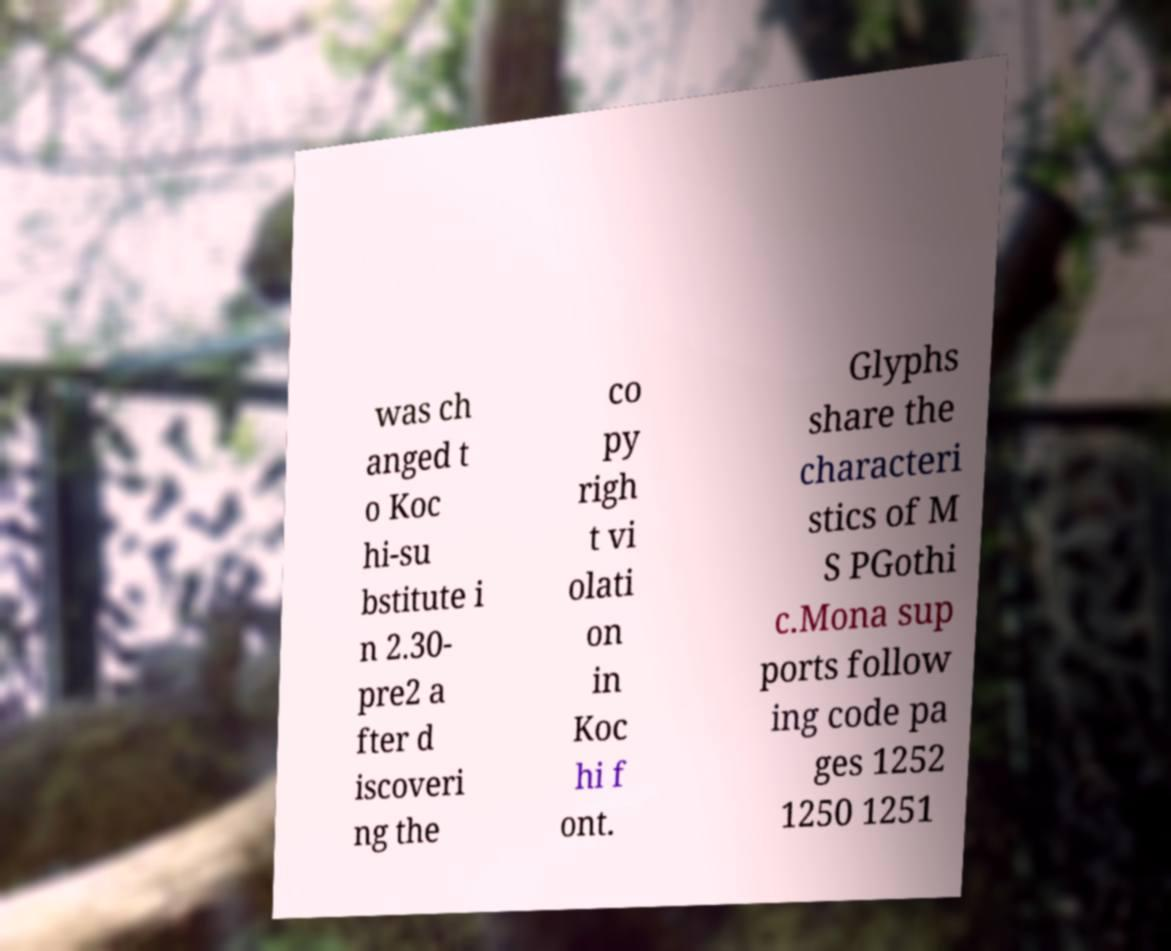For documentation purposes, I need the text within this image transcribed. Could you provide that? was ch anged t o Koc hi-su bstitute i n 2.30- pre2 a fter d iscoveri ng the co py righ t vi olati on in Koc hi f ont. Glyphs share the characteri stics of M S PGothi c.Mona sup ports follow ing code pa ges 1252 1250 1251 